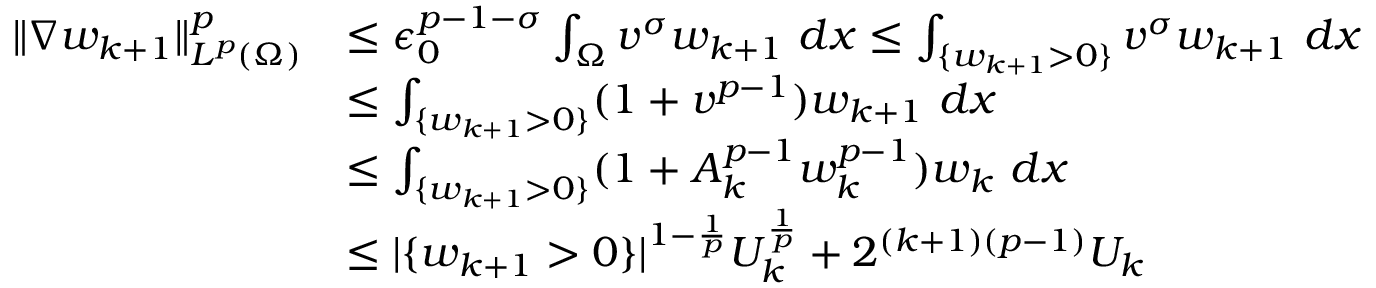<formula> <loc_0><loc_0><loc_500><loc_500>\begin{array} { r l } { \| \nabla w _ { k + 1 } \| _ { L ^ { p } ( \Omega ) } ^ { p } } & { \leq \epsilon _ { 0 } ^ { p - 1 - \sigma } \int _ { \Omega } v ^ { \sigma } w _ { k + 1 } \ d x \leq \int _ { \{ w _ { k + 1 } > 0 \} } v ^ { \sigma } w _ { k + 1 } \ d x } \\ & { \leq \int _ { \{ w _ { k + 1 } > 0 \} } ( 1 + v ^ { p - 1 } ) w _ { k + 1 } \ d x } \\ & { \leq \int _ { \{ w _ { k + 1 } > 0 \} } ( 1 + A _ { k } ^ { p - 1 } w _ { k } ^ { p - 1 } ) w _ { k } \ d x } \\ & { \leq | \{ w _ { k + 1 } > 0 \} | ^ { 1 - \frac { 1 } { p } } U _ { k } ^ { \frac { 1 } { p } } + 2 ^ { ( k + 1 ) ( p - 1 ) } U _ { k } } \end{array}</formula> 